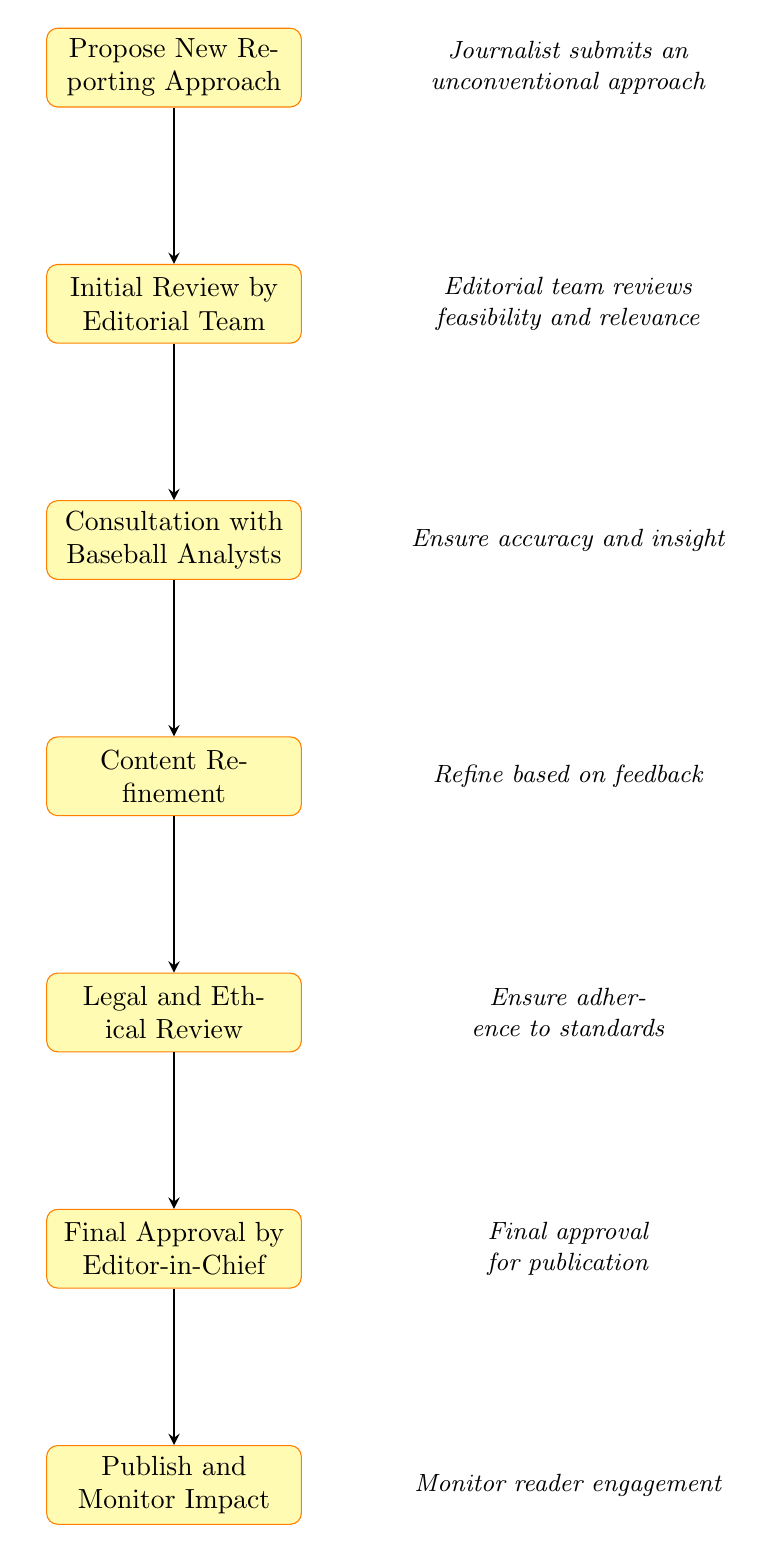What is the first step in the editorial review cycle? The first step in the diagram is represented by the node labeled "Propose New Reporting Approach".
Answer: Propose New Reporting Approach How many nodes are in the diagram? The diagram contains a total of seven nodes, each representing a step in the editorial review cycle.
Answer: 7 What are the nodes immediately before "Publish and Monitor Impact"? The node immediately before "Publish and Monitor Impact" is "Final Approval by Editor-in-Chief".
Answer: Final Approval by Editor-in-Chief Which step involves engaging with baseball analysts? The step labeled "Consultation with Baseball Analysts" directly corresponds to engaging with baseball analysts.
Answer: Consultation with Baseball Analysts What is the final step in the review cycle? The final step is indicated by the node "Publish and Monitor Impact", which is the last action taken after approvals.
Answer: Publish and Monitor Impact What is the relationship between "Legal and Ethical Review" and "Final Approval by Editor-in-Chief"? "Legal and Ethical Review" must be completed before it leads to "Final Approval by Editor-in-Chief", indicating a sequential flow in the process.
Answer: Sequential flow What must occur after content refinement? After content refinement, "Legal and Ethical Review" must occur, as depicted sequentially in the flowchart.
Answer: Legal and Ethical Review How do you ensure the new approach adheres to standards? This is ensured during the step labeled "Legal and Ethical Review", where adherence to legal standards and ethical guidelines is evaluated.
Answer: Legal and Ethical Review What happens after "Initial Review by Editorial Team"? After "Initial Review by Editorial Team", the next step in the cycle is "Consultation with Baseball Analysts".
Answer: Consultation with Baseball Analysts 